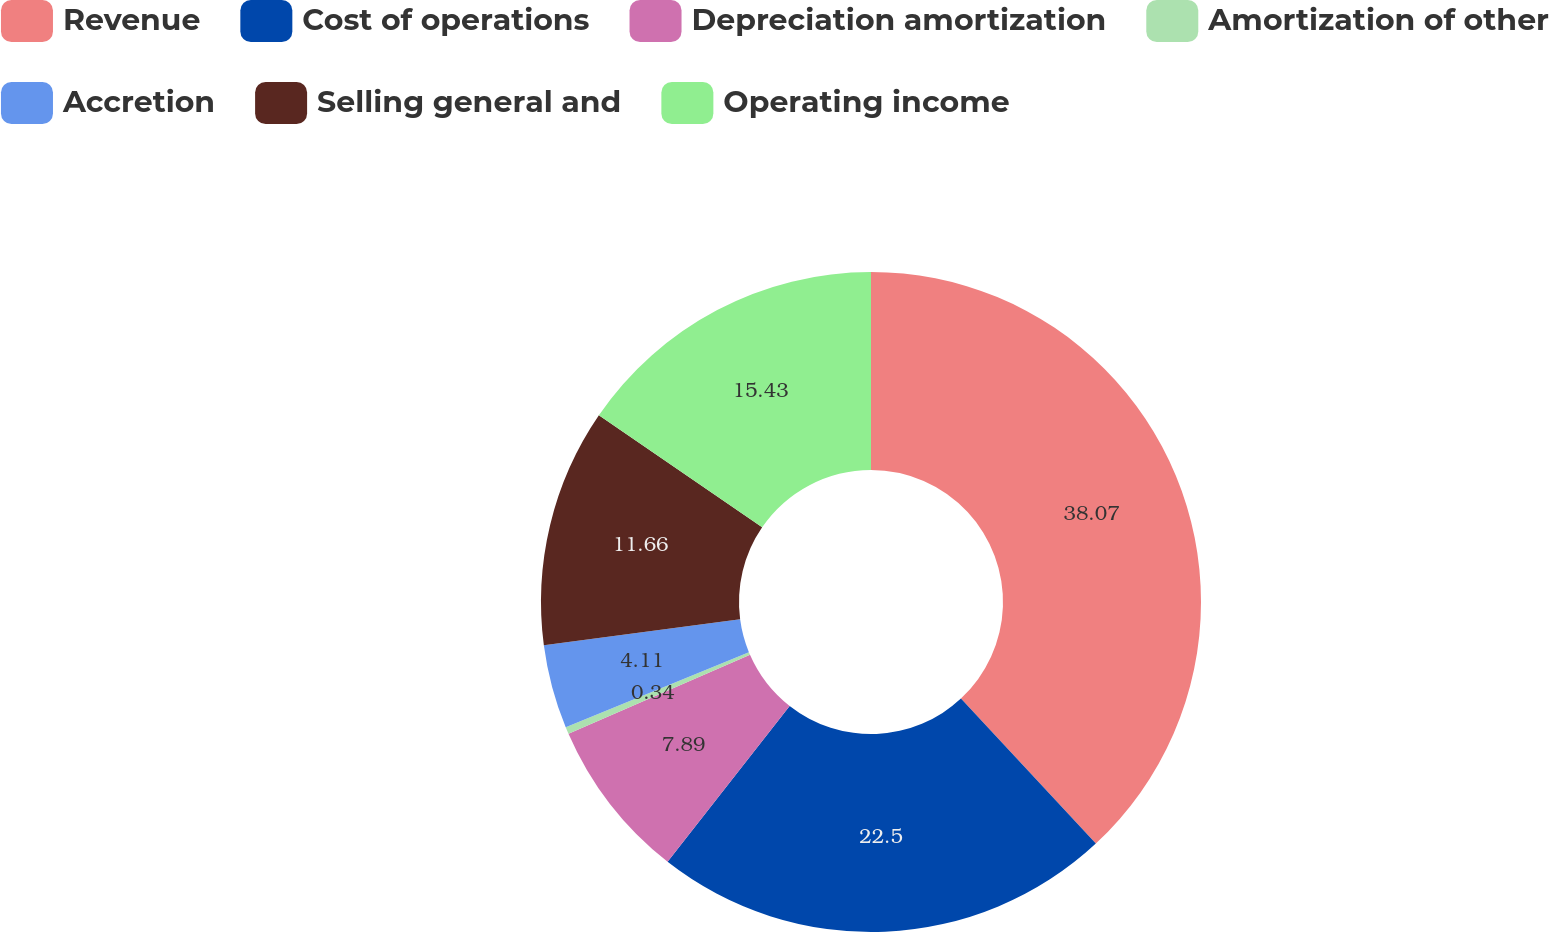Convert chart. <chart><loc_0><loc_0><loc_500><loc_500><pie_chart><fcel>Revenue<fcel>Cost of operations<fcel>Depreciation amortization<fcel>Amortization of other<fcel>Accretion<fcel>Selling general and<fcel>Operating income<nl><fcel>38.07%<fcel>22.5%<fcel>7.89%<fcel>0.34%<fcel>4.11%<fcel>11.66%<fcel>15.43%<nl></chart> 